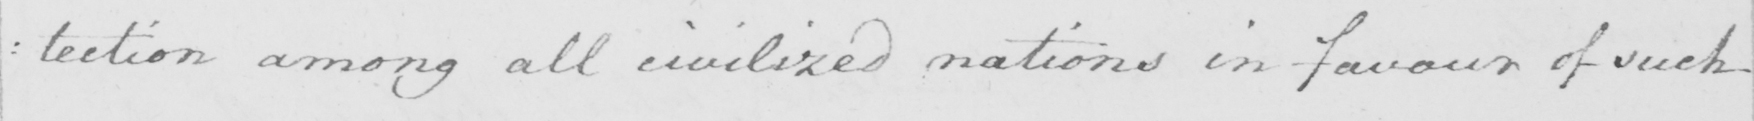What does this handwritten line say? : tection among all civilized nations in favour of such 